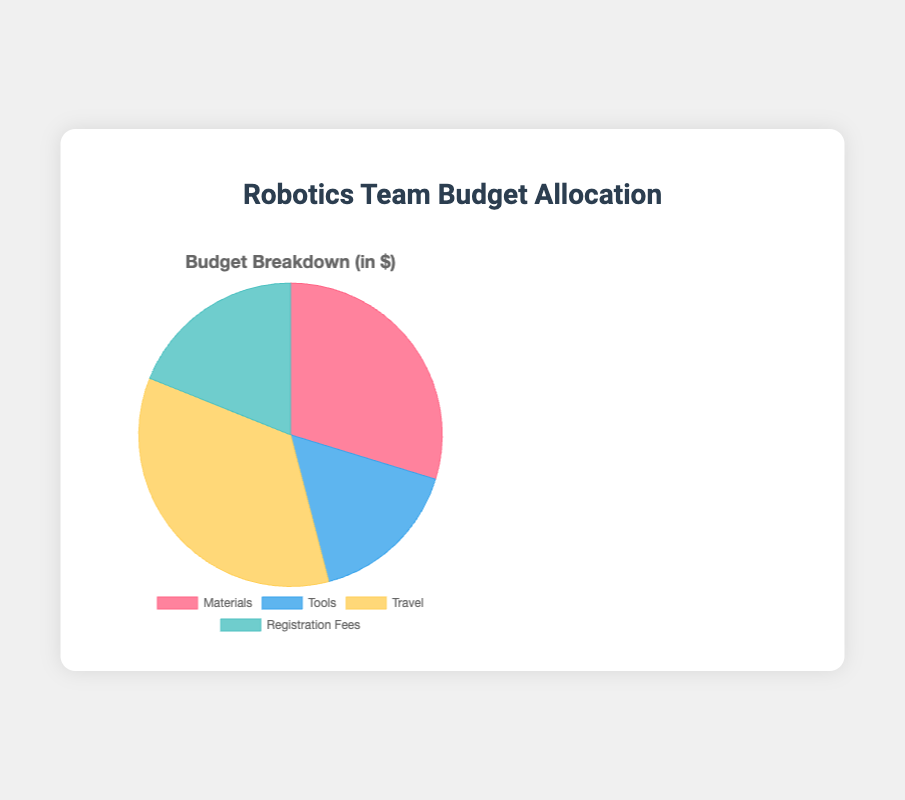Which category has the highest budget allocation? The chart shows the budget allocation for four categories. The segment representing "Travel" is the largest.
Answer: Travel What is the total budget for all categories combined? Sum the values of all categories: Materials ($1100) + Tools ($600) + Travel ($1300) + Registration Fees ($700) = $3700.
Answer: $3700 How much more is spent on Travel than on Tools? The budget for Travel is $1300 and for Tools is $600. The difference is $1300 - $600 = $700.
Answer: $700 What percentage of the total budget is allocated to Materials? Materials have a budget of $1100 out of the total $3700. The percentage is (1100 / 3700) * 100 ≈ 29.73%.
Answer: 29.73% Which category has the smallest budget allocation? The chart shows the budget allocation for four categories. The segment representing "Tools" is the smallest.
Answer: Tools If the budget for Registration Fees is increased by 50%, what would be the new total budget? Increase the budget for Registration Fees by 50%: $700 + ($700 * 0.5) = $700 + $350 = $1050. New total budget: $3700 - $700 + $1050 = $4050.
Answer: $4050 What is the average budget allocation for the categories? Sum the values of all categories: $3700. There are four categories, so the average budget is $3700 / 4 = $925.
Answer: $925 By how much does the Transportation (under Travel) budget compare to the entire Tools budget? The Transportation budget is $400, and the Tools budget is $600.
Answer: $400 is smaller than $600 How much would we have left if we removed the budget for the categories with a budget allocation less than $1000? Tools ($600) and Registration Fees ($700) are less than $1000. Removing these: $3700 - $600 - $700 = $2400.
Answer: $2400 